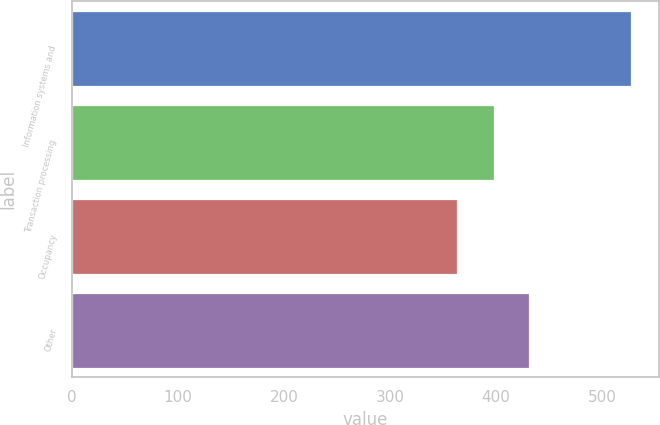Convert chart. <chart><loc_0><loc_0><loc_500><loc_500><bar_chart><fcel>Information systems and<fcel>Transaction processing<fcel>Occupancy<fcel>Other<nl><fcel>527<fcel>398<fcel>363<fcel>431<nl></chart> 